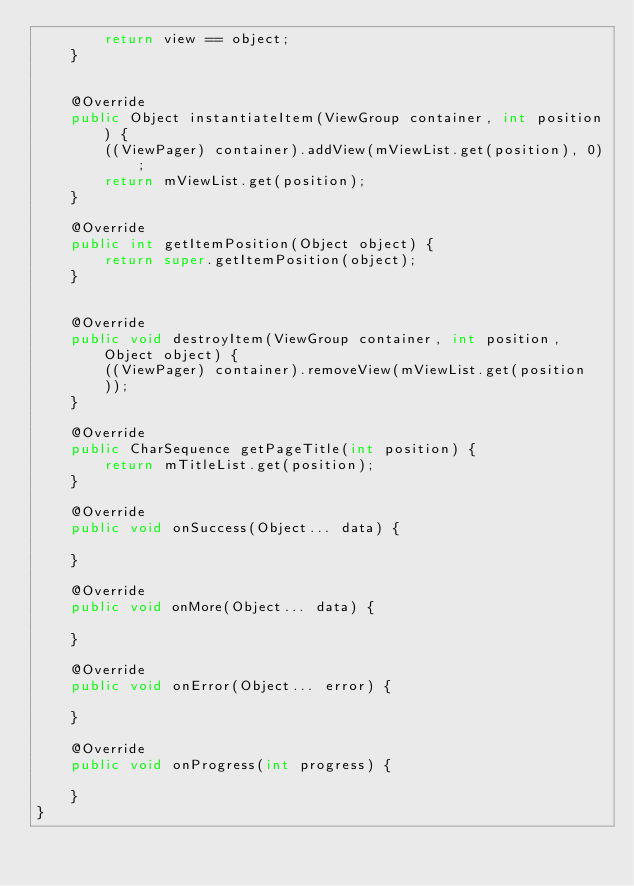<code> <loc_0><loc_0><loc_500><loc_500><_Java_>        return view == object;
    }


    @Override
    public Object instantiateItem(ViewGroup container, int position) {
        ((ViewPager) container).addView(mViewList.get(position), 0);
        return mViewList.get(position);
    }

    @Override
    public int getItemPosition(Object object) {
        return super.getItemPosition(object);
    }


    @Override
    public void destroyItem(ViewGroup container, int position, Object object) {
        ((ViewPager) container).removeView(mViewList.get(position
        ));
    }

    @Override
    public CharSequence getPageTitle(int position) {
        return mTitleList.get(position);
    }

    @Override
    public void onSuccess(Object... data) {

    }

    @Override
    public void onMore(Object... data) {

    }

    @Override
    public void onError(Object... error) {

    }

    @Override
    public void onProgress(int progress) {

    }
}
</code> 